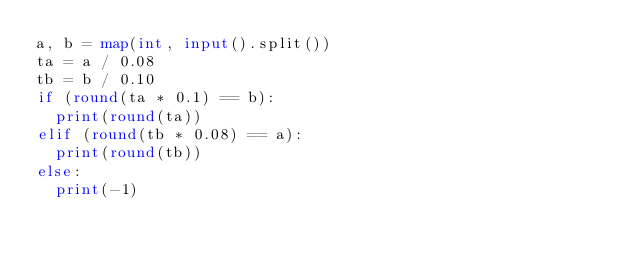Convert code to text. <code><loc_0><loc_0><loc_500><loc_500><_Python_>a, b = map(int, input().split())
ta = a / 0.08
tb = b / 0.10
if (round(ta * 0.1) == b):
  print(round(ta))
elif (round(tb * 0.08) == a):
  print(round(tb))
else:
  print(-1)
</code> 